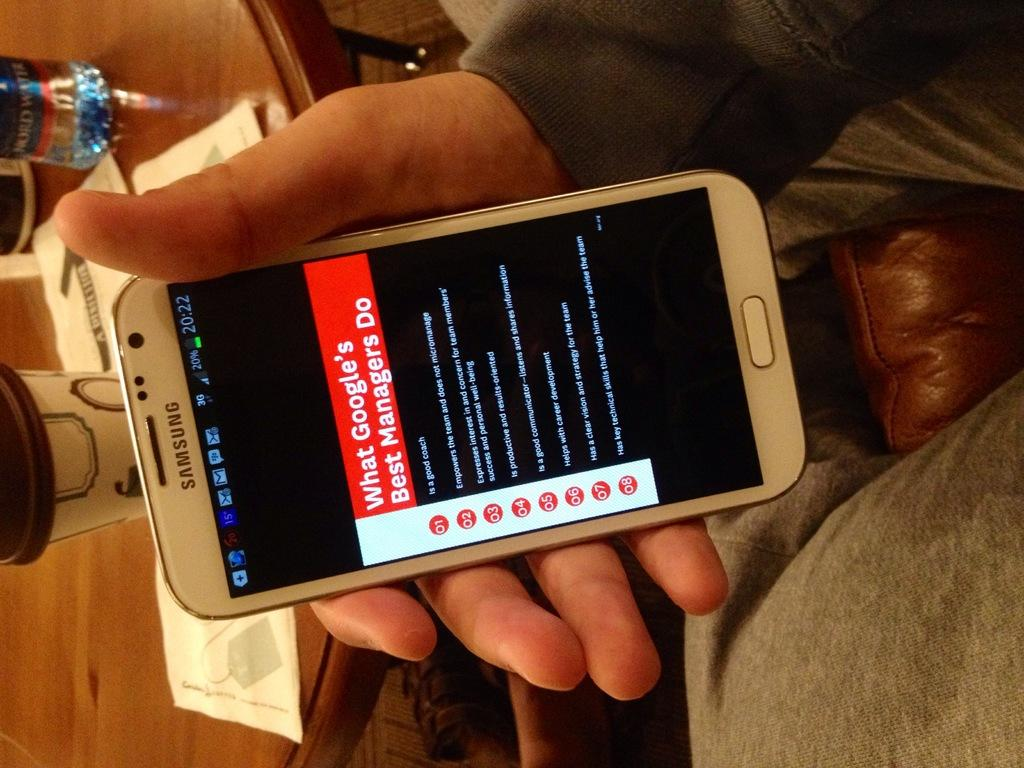<image>
Create a compact narrative representing the image presented. a person has looked up what googles best managers do 